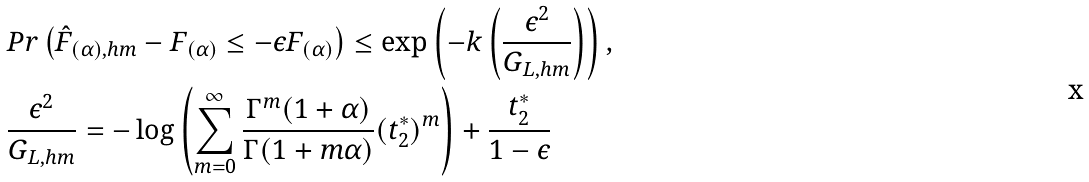<formula> <loc_0><loc_0><loc_500><loc_500>& P r \left ( \hat { F } _ { ( \alpha ) , h m } - F _ { ( \alpha ) } \leq - \epsilon F _ { ( \alpha ) } \right ) \leq \exp \left ( - k \left ( \frac { \epsilon ^ { 2 } } { G _ { L , h m } } \right ) \right ) , \\ & \frac { \epsilon ^ { 2 } } { G _ { L , h m } } = - \log \left ( \sum _ { m = 0 } ^ { \infty } \frac { \Gamma ^ { m } ( 1 + \alpha ) } { \Gamma ( 1 + m \alpha ) } ( t _ { 2 } ^ { * } ) ^ { m } \right ) + \frac { t _ { 2 } ^ { * } } { 1 - \epsilon }</formula> 